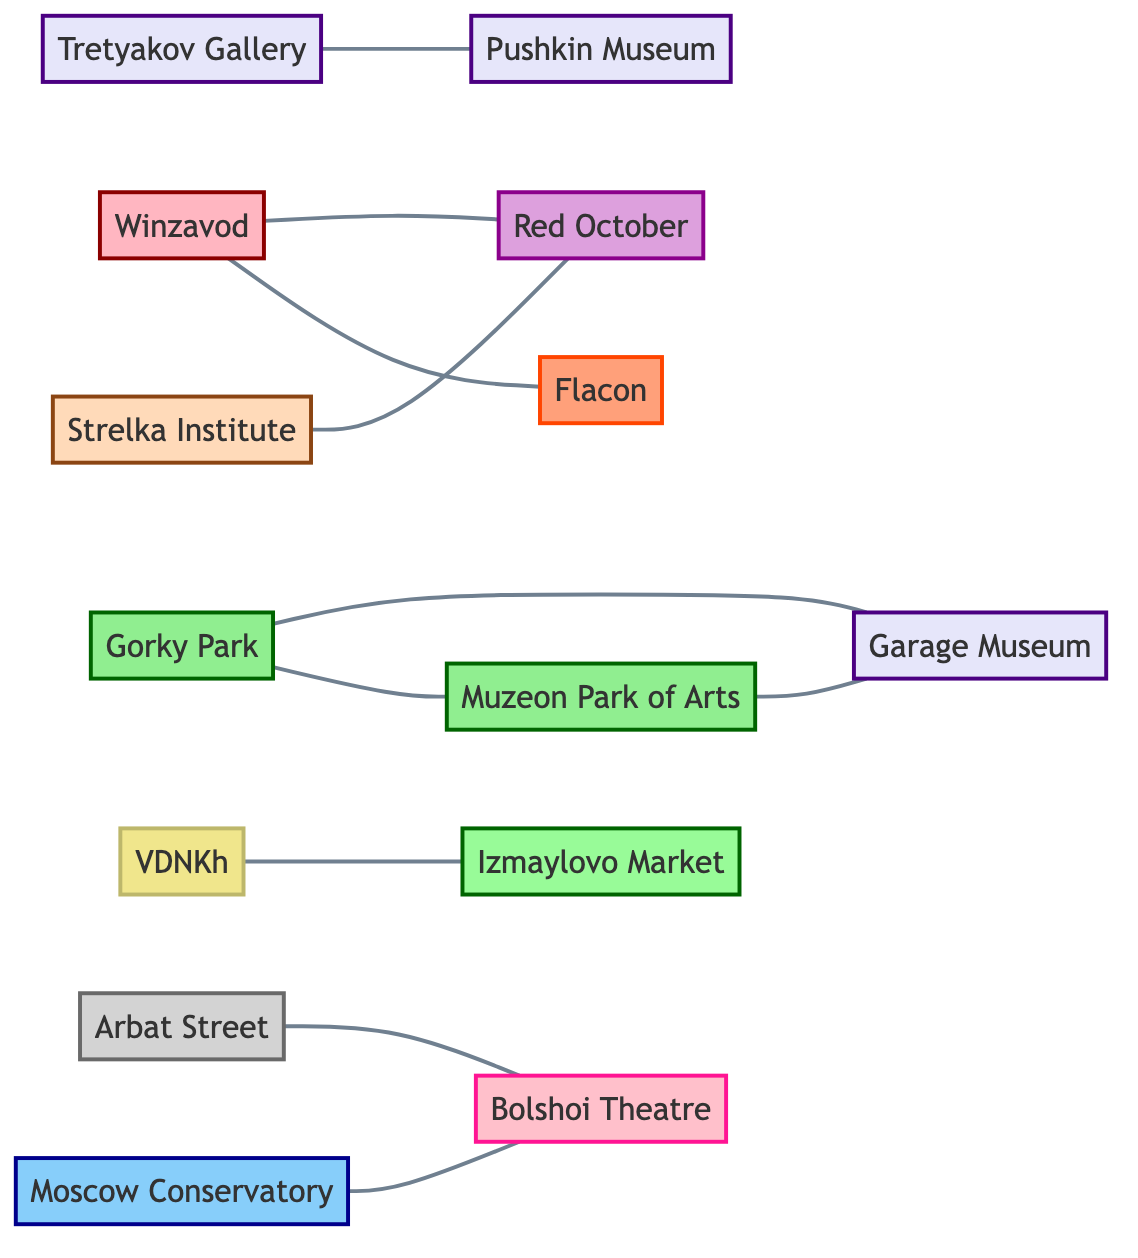What is the total number of nodes in the graph? The diagram contains multiple nodes representing different cultural spots in Moscow. By counting each unique location listed, we find there are fifteen nodes in total.
Answer: 15 Which two nodes are directly connected to Gorky Park? Gorky Park is connected to two nodes: Muzeon Park of Arts and Garage Museum of Contemporary Art. A direct connection is evident as edges link Gorky Park to these two locations.
Answer: Muzeon Park of Arts, Garage Museum of Contemporary Art How many museums are depicted in the graph? The graph includes various types of cultural spots, and specifically identifies four nodes as museums: Tretyakov Gallery, Pushkin Museum, Garage Museum of Contemporary Art, and Muzeon Park of Arts. Counting these gives us four museums.
Answer: 4 Which cultural center is connected to the Strelka Institute? The graph shows a direct connection between the Strelka Institute and the Red October cultural center. An edge directly links these two nodes in the diagram.
Answer: Red October What type of location is the Bolshoi Theatre? The Bolshoi Theatre node is classified as a theatre per its labeling in the diagram's node definitions. Therefore, its specific type is easily identifiable.
Answer: theatre How many edges are present in the graph? Edges represent the connections between the individual nodes. By counting all distinct edges (relationships) shown in the diagram, we find there are ten edges in total.
Answer: 10 Which park is connected to the Moscow Conservatory? The Moscow Conservatory node is linked directly to the Bolshoi Theatre, thus, it has no direct park connection based on the provided edges. However, it finds itself in context with the cultural landscape surrounding it.
Answer: None How do galleries relate to parks in this diagram? There are connections indicated between one gallery and one park. The Garage Museum of Contemporary Art is directly linked to both Gorky Park and Muzeon Park of Arts, showcasing a relationship between galleries and parks.
Answer: Gorky Park, Muzeon Park of Arts Which market is connected to the exhibition center VDNKh? VDNKh is directly connected to the Izmaylovo Market as evidenced by the edge linking these two nodes in the diagram.
Answer: Izmaylovo Market 